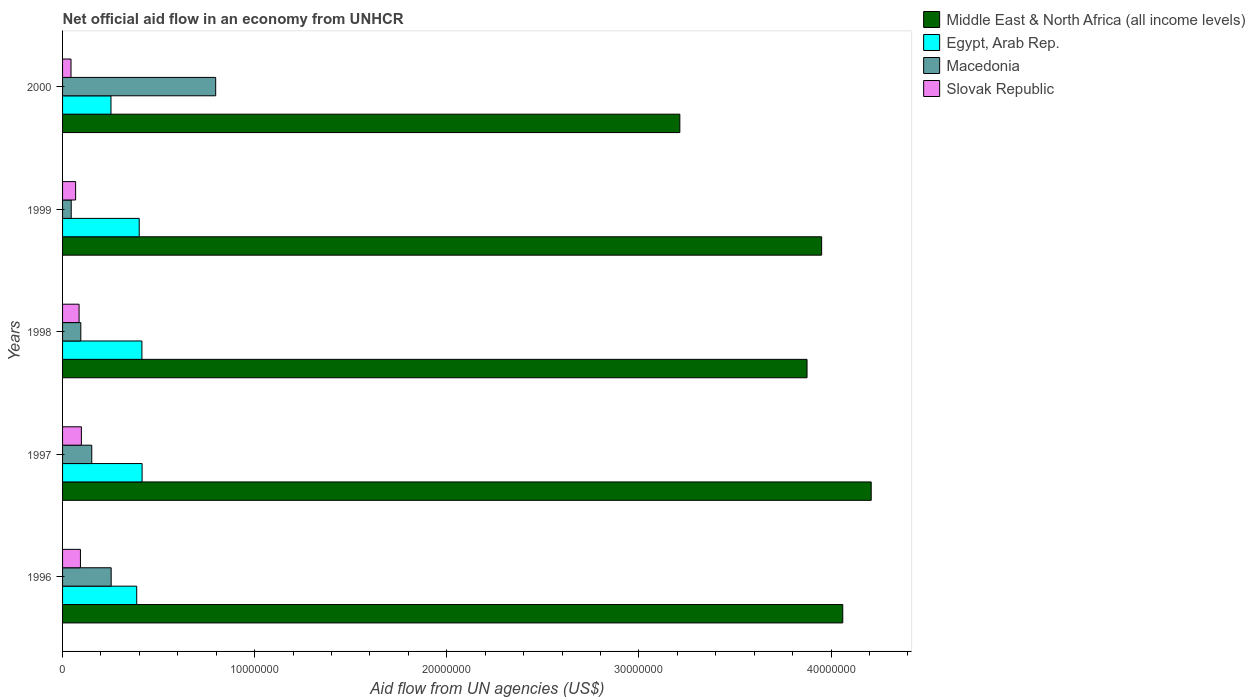How many different coloured bars are there?
Your answer should be compact. 4. How many groups of bars are there?
Make the answer very short. 5. How many bars are there on the 2nd tick from the top?
Give a very brief answer. 4. How many bars are there on the 3rd tick from the bottom?
Keep it short and to the point. 4. In how many cases, is the number of bars for a given year not equal to the number of legend labels?
Offer a very short reply. 0. What is the net official aid flow in Slovak Republic in 1997?
Ensure brevity in your answer.  9.80e+05. Across all years, what is the maximum net official aid flow in Egypt, Arab Rep.?
Ensure brevity in your answer.  4.14e+06. Across all years, what is the minimum net official aid flow in Slovak Republic?
Give a very brief answer. 4.40e+05. In which year was the net official aid flow in Macedonia maximum?
Ensure brevity in your answer.  2000. In which year was the net official aid flow in Slovak Republic minimum?
Offer a terse response. 2000. What is the total net official aid flow in Middle East & North Africa (all income levels) in the graph?
Provide a succinct answer. 1.93e+08. What is the difference between the net official aid flow in Macedonia in 1996 and that in 2000?
Your answer should be very brief. -5.44e+06. What is the difference between the net official aid flow in Egypt, Arab Rep. in 1998 and the net official aid flow in Macedonia in 1999?
Ensure brevity in your answer.  3.68e+06. What is the average net official aid flow in Macedonia per year?
Provide a short and direct response. 2.68e+06. In the year 1997, what is the difference between the net official aid flow in Egypt, Arab Rep. and net official aid flow in Slovak Republic?
Offer a very short reply. 3.16e+06. What is the ratio of the net official aid flow in Egypt, Arab Rep. in 1996 to that in 2000?
Make the answer very short. 1.53. What is the difference between the highest and the second highest net official aid flow in Middle East & North Africa (all income levels)?
Provide a succinct answer. 1.48e+06. What is the difference between the highest and the lowest net official aid flow in Middle East & North Africa (all income levels)?
Provide a succinct answer. 9.96e+06. In how many years, is the net official aid flow in Middle East & North Africa (all income levels) greater than the average net official aid flow in Middle East & North Africa (all income levels) taken over all years?
Offer a terse response. 4. What does the 3rd bar from the top in 1998 represents?
Your answer should be compact. Egypt, Arab Rep. What does the 3rd bar from the bottom in 1999 represents?
Make the answer very short. Macedonia. Is it the case that in every year, the sum of the net official aid flow in Egypt, Arab Rep. and net official aid flow in Macedonia is greater than the net official aid flow in Slovak Republic?
Your answer should be very brief. Yes. Are all the bars in the graph horizontal?
Offer a terse response. Yes. What is the difference between two consecutive major ticks on the X-axis?
Keep it short and to the point. 1.00e+07. Does the graph contain any zero values?
Give a very brief answer. No. Does the graph contain grids?
Offer a terse response. No. Where does the legend appear in the graph?
Ensure brevity in your answer.  Top right. How many legend labels are there?
Keep it short and to the point. 4. What is the title of the graph?
Provide a short and direct response. Net official aid flow in an economy from UNHCR. What is the label or title of the X-axis?
Provide a succinct answer. Aid flow from UN agencies (US$). What is the label or title of the Y-axis?
Your response must be concise. Years. What is the Aid flow from UN agencies (US$) of Middle East & North Africa (all income levels) in 1996?
Your answer should be very brief. 4.06e+07. What is the Aid flow from UN agencies (US$) in Egypt, Arab Rep. in 1996?
Provide a succinct answer. 3.86e+06. What is the Aid flow from UN agencies (US$) of Macedonia in 1996?
Provide a succinct answer. 2.53e+06. What is the Aid flow from UN agencies (US$) of Slovak Republic in 1996?
Offer a terse response. 9.30e+05. What is the Aid flow from UN agencies (US$) in Middle East & North Africa (all income levels) in 1997?
Make the answer very short. 4.21e+07. What is the Aid flow from UN agencies (US$) in Egypt, Arab Rep. in 1997?
Make the answer very short. 4.14e+06. What is the Aid flow from UN agencies (US$) in Macedonia in 1997?
Your answer should be very brief. 1.52e+06. What is the Aid flow from UN agencies (US$) in Slovak Republic in 1997?
Your answer should be compact. 9.80e+05. What is the Aid flow from UN agencies (US$) of Middle East & North Africa (all income levels) in 1998?
Ensure brevity in your answer.  3.88e+07. What is the Aid flow from UN agencies (US$) in Egypt, Arab Rep. in 1998?
Provide a short and direct response. 4.13e+06. What is the Aid flow from UN agencies (US$) in Macedonia in 1998?
Your response must be concise. 9.50e+05. What is the Aid flow from UN agencies (US$) in Slovak Republic in 1998?
Give a very brief answer. 8.60e+05. What is the Aid flow from UN agencies (US$) in Middle East & North Africa (all income levels) in 1999?
Provide a short and direct response. 3.95e+07. What is the Aid flow from UN agencies (US$) of Egypt, Arab Rep. in 1999?
Your response must be concise. 3.99e+06. What is the Aid flow from UN agencies (US$) of Slovak Republic in 1999?
Give a very brief answer. 6.80e+05. What is the Aid flow from UN agencies (US$) in Middle East & North Africa (all income levels) in 2000?
Your answer should be compact. 3.21e+07. What is the Aid flow from UN agencies (US$) of Egypt, Arab Rep. in 2000?
Keep it short and to the point. 2.52e+06. What is the Aid flow from UN agencies (US$) in Macedonia in 2000?
Your response must be concise. 7.97e+06. Across all years, what is the maximum Aid flow from UN agencies (US$) of Middle East & North Africa (all income levels)?
Make the answer very short. 4.21e+07. Across all years, what is the maximum Aid flow from UN agencies (US$) in Egypt, Arab Rep.?
Offer a very short reply. 4.14e+06. Across all years, what is the maximum Aid flow from UN agencies (US$) of Macedonia?
Give a very brief answer. 7.97e+06. Across all years, what is the maximum Aid flow from UN agencies (US$) of Slovak Republic?
Ensure brevity in your answer.  9.80e+05. Across all years, what is the minimum Aid flow from UN agencies (US$) of Middle East & North Africa (all income levels)?
Make the answer very short. 3.21e+07. Across all years, what is the minimum Aid flow from UN agencies (US$) in Egypt, Arab Rep.?
Make the answer very short. 2.52e+06. Across all years, what is the minimum Aid flow from UN agencies (US$) of Slovak Republic?
Ensure brevity in your answer.  4.40e+05. What is the total Aid flow from UN agencies (US$) in Middle East & North Africa (all income levels) in the graph?
Offer a terse response. 1.93e+08. What is the total Aid flow from UN agencies (US$) of Egypt, Arab Rep. in the graph?
Your answer should be very brief. 1.86e+07. What is the total Aid flow from UN agencies (US$) in Macedonia in the graph?
Keep it short and to the point. 1.34e+07. What is the total Aid flow from UN agencies (US$) in Slovak Republic in the graph?
Offer a terse response. 3.89e+06. What is the difference between the Aid flow from UN agencies (US$) of Middle East & North Africa (all income levels) in 1996 and that in 1997?
Make the answer very short. -1.48e+06. What is the difference between the Aid flow from UN agencies (US$) in Egypt, Arab Rep. in 1996 and that in 1997?
Offer a very short reply. -2.80e+05. What is the difference between the Aid flow from UN agencies (US$) in Macedonia in 1996 and that in 1997?
Ensure brevity in your answer.  1.01e+06. What is the difference between the Aid flow from UN agencies (US$) of Middle East & North Africa (all income levels) in 1996 and that in 1998?
Your answer should be compact. 1.86e+06. What is the difference between the Aid flow from UN agencies (US$) in Egypt, Arab Rep. in 1996 and that in 1998?
Make the answer very short. -2.70e+05. What is the difference between the Aid flow from UN agencies (US$) in Macedonia in 1996 and that in 1998?
Your response must be concise. 1.58e+06. What is the difference between the Aid flow from UN agencies (US$) in Slovak Republic in 1996 and that in 1998?
Your answer should be very brief. 7.00e+04. What is the difference between the Aid flow from UN agencies (US$) in Middle East & North Africa (all income levels) in 1996 and that in 1999?
Offer a terse response. 1.10e+06. What is the difference between the Aid flow from UN agencies (US$) of Macedonia in 1996 and that in 1999?
Your response must be concise. 2.08e+06. What is the difference between the Aid flow from UN agencies (US$) of Middle East & North Africa (all income levels) in 1996 and that in 2000?
Your answer should be very brief. 8.48e+06. What is the difference between the Aid flow from UN agencies (US$) of Egypt, Arab Rep. in 1996 and that in 2000?
Your response must be concise. 1.34e+06. What is the difference between the Aid flow from UN agencies (US$) in Macedonia in 1996 and that in 2000?
Provide a short and direct response. -5.44e+06. What is the difference between the Aid flow from UN agencies (US$) in Middle East & North Africa (all income levels) in 1997 and that in 1998?
Provide a succinct answer. 3.34e+06. What is the difference between the Aid flow from UN agencies (US$) of Macedonia in 1997 and that in 1998?
Offer a very short reply. 5.70e+05. What is the difference between the Aid flow from UN agencies (US$) in Middle East & North Africa (all income levels) in 1997 and that in 1999?
Your answer should be very brief. 2.58e+06. What is the difference between the Aid flow from UN agencies (US$) of Macedonia in 1997 and that in 1999?
Your answer should be compact. 1.07e+06. What is the difference between the Aid flow from UN agencies (US$) of Middle East & North Africa (all income levels) in 1997 and that in 2000?
Keep it short and to the point. 9.96e+06. What is the difference between the Aid flow from UN agencies (US$) of Egypt, Arab Rep. in 1997 and that in 2000?
Your answer should be compact. 1.62e+06. What is the difference between the Aid flow from UN agencies (US$) in Macedonia in 1997 and that in 2000?
Ensure brevity in your answer.  -6.45e+06. What is the difference between the Aid flow from UN agencies (US$) in Slovak Republic in 1997 and that in 2000?
Ensure brevity in your answer.  5.40e+05. What is the difference between the Aid flow from UN agencies (US$) of Middle East & North Africa (all income levels) in 1998 and that in 1999?
Provide a short and direct response. -7.60e+05. What is the difference between the Aid flow from UN agencies (US$) in Macedonia in 1998 and that in 1999?
Your answer should be very brief. 5.00e+05. What is the difference between the Aid flow from UN agencies (US$) in Middle East & North Africa (all income levels) in 1998 and that in 2000?
Make the answer very short. 6.62e+06. What is the difference between the Aid flow from UN agencies (US$) in Egypt, Arab Rep. in 1998 and that in 2000?
Give a very brief answer. 1.61e+06. What is the difference between the Aid flow from UN agencies (US$) of Macedonia in 1998 and that in 2000?
Provide a short and direct response. -7.02e+06. What is the difference between the Aid flow from UN agencies (US$) of Middle East & North Africa (all income levels) in 1999 and that in 2000?
Ensure brevity in your answer.  7.38e+06. What is the difference between the Aid flow from UN agencies (US$) in Egypt, Arab Rep. in 1999 and that in 2000?
Offer a very short reply. 1.47e+06. What is the difference between the Aid flow from UN agencies (US$) in Macedonia in 1999 and that in 2000?
Your answer should be very brief. -7.52e+06. What is the difference between the Aid flow from UN agencies (US$) of Slovak Republic in 1999 and that in 2000?
Give a very brief answer. 2.40e+05. What is the difference between the Aid flow from UN agencies (US$) in Middle East & North Africa (all income levels) in 1996 and the Aid flow from UN agencies (US$) in Egypt, Arab Rep. in 1997?
Give a very brief answer. 3.65e+07. What is the difference between the Aid flow from UN agencies (US$) in Middle East & North Africa (all income levels) in 1996 and the Aid flow from UN agencies (US$) in Macedonia in 1997?
Offer a terse response. 3.91e+07. What is the difference between the Aid flow from UN agencies (US$) in Middle East & North Africa (all income levels) in 1996 and the Aid flow from UN agencies (US$) in Slovak Republic in 1997?
Offer a very short reply. 3.96e+07. What is the difference between the Aid flow from UN agencies (US$) in Egypt, Arab Rep. in 1996 and the Aid flow from UN agencies (US$) in Macedonia in 1997?
Your response must be concise. 2.34e+06. What is the difference between the Aid flow from UN agencies (US$) of Egypt, Arab Rep. in 1996 and the Aid flow from UN agencies (US$) of Slovak Republic in 1997?
Provide a short and direct response. 2.88e+06. What is the difference between the Aid flow from UN agencies (US$) of Macedonia in 1996 and the Aid flow from UN agencies (US$) of Slovak Republic in 1997?
Your answer should be very brief. 1.55e+06. What is the difference between the Aid flow from UN agencies (US$) in Middle East & North Africa (all income levels) in 1996 and the Aid flow from UN agencies (US$) in Egypt, Arab Rep. in 1998?
Your answer should be compact. 3.65e+07. What is the difference between the Aid flow from UN agencies (US$) of Middle East & North Africa (all income levels) in 1996 and the Aid flow from UN agencies (US$) of Macedonia in 1998?
Offer a very short reply. 3.97e+07. What is the difference between the Aid flow from UN agencies (US$) in Middle East & North Africa (all income levels) in 1996 and the Aid flow from UN agencies (US$) in Slovak Republic in 1998?
Give a very brief answer. 3.98e+07. What is the difference between the Aid flow from UN agencies (US$) of Egypt, Arab Rep. in 1996 and the Aid flow from UN agencies (US$) of Macedonia in 1998?
Provide a succinct answer. 2.91e+06. What is the difference between the Aid flow from UN agencies (US$) of Egypt, Arab Rep. in 1996 and the Aid flow from UN agencies (US$) of Slovak Republic in 1998?
Provide a short and direct response. 3.00e+06. What is the difference between the Aid flow from UN agencies (US$) of Macedonia in 1996 and the Aid flow from UN agencies (US$) of Slovak Republic in 1998?
Provide a succinct answer. 1.67e+06. What is the difference between the Aid flow from UN agencies (US$) in Middle East & North Africa (all income levels) in 1996 and the Aid flow from UN agencies (US$) in Egypt, Arab Rep. in 1999?
Your answer should be very brief. 3.66e+07. What is the difference between the Aid flow from UN agencies (US$) in Middle East & North Africa (all income levels) in 1996 and the Aid flow from UN agencies (US$) in Macedonia in 1999?
Give a very brief answer. 4.02e+07. What is the difference between the Aid flow from UN agencies (US$) in Middle East & North Africa (all income levels) in 1996 and the Aid flow from UN agencies (US$) in Slovak Republic in 1999?
Offer a very short reply. 3.99e+07. What is the difference between the Aid flow from UN agencies (US$) of Egypt, Arab Rep. in 1996 and the Aid flow from UN agencies (US$) of Macedonia in 1999?
Keep it short and to the point. 3.41e+06. What is the difference between the Aid flow from UN agencies (US$) in Egypt, Arab Rep. in 1996 and the Aid flow from UN agencies (US$) in Slovak Republic in 1999?
Your answer should be compact. 3.18e+06. What is the difference between the Aid flow from UN agencies (US$) in Macedonia in 1996 and the Aid flow from UN agencies (US$) in Slovak Republic in 1999?
Your answer should be compact. 1.85e+06. What is the difference between the Aid flow from UN agencies (US$) of Middle East & North Africa (all income levels) in 1996 and the Aid flow from UN agencies (US$) of Egypt, Arab Rep. in 2000?
Provide a succinct answer. 3.81e+07. What is the difference between the Aid flow from UN agencies (US$) in Middle East & North Africa (all income levels) in 1996 and the Aid flow from UN agencies (US$) in Macedonia in 2000?
Provide a succinct answer. 3.26e+07. What is the difference between the Aid flow from UN agencies (US$) of Middle East & North Africa (all income levels) in 1996 and the Aid flow from UN agencies (US$) of Slovak Republic in 2000?
Make the answer very short. 4.02e+07. What is the difference between the Aid flow from UN agencies (US$) in Egypt, Arab Rep. in 1996 and the Aid flow from UN agencies (US$) in Macedonia in 2000?
Make the answer very short. -4.11e+06. What is the difference between the Aid flow from UN agencies (US$) of Egypt, Arab Rep. in 1996 and the Aid flow from UN agencies (US$) of Slovak Republic in 2000?
Offer a very short reply. 3.42e+06. What is the difference between the Aid flow from UN agencies (US$) of Macedonia in 1996 and the Aid flow from UN agencies (US$) of Slovak Republic in 2000?
Offer a very short reply. 2.09e+06. What is the difference between the Aid flow from UN agencies (US$) in Middle East & North Africa (all income levels) in 1997 and the Aid flow from UN agencies (US$) in Egypt, Arab Rep. in 1998?
Your answer should be compact. 3.80e+07. What is the difference between the Aid flow from UN agencies (US$) in Middle East & North Africa (all income levels) in 1997 and the Aid flow from UN agencies (US$) in Macedonia in 1998?
Ensure brevity in your answer.  4.11e+07. What is the difference between the Aid flow from UN agencies (US$) in Middle East & North Africa (all income levels) in 1997 and the Aid flow from UN agencies (US$) in Slovak Republic in 1998?
Your answer should be very brief. 4.12e+07. What is the difference between the Aid flow from UN agencies (US$) in Egypt, Arab Rep. in 1997 and the Aid flow from UN agencies (US$) in Macedonia in 1998?
Your answer should be compact. 3.19e+06. What is the difference between the Aid flow from UN agencies (US$) of Egypt, Arab Rep. in 1997 and the Aid flow from UN agencies (US$) of Slovak Republic in 1998?
Provide a succinct answer. 3.28e+06. What is the difference between the Aid flow from UN agencies (US$) of Macedonia in 1997 and the Aid flow from UN agencies (US$) of Slovak Republic in 1998?
Offer a terse response. 6.60e+05. What is the difference between the Aid flow from UN agencies (US$) in Middle East & North Africa (all income levels) in 1997 and the Aid flow from UN agencies (US$) in Egypt, Arab Rep. in 1999?
Make the answer very short. 3.81e+07. What is the difference between the Aid flow from UN agencies (US$) of Middle East & North Africa (all income levels) in 1997 and the Aid flow from UN agencies (US$) of Macedonia in 1999?
Ensure brevity in your answer.  4.16e+07. What is the difference between the Aid flow from UN agencies (US$) of Middle East & North Africa (all income levels) in 1997 and the Aid flow from UN agencies (US$) of Slovak Republic in 1999?
Ensure brevity in your answer.  4.14e+07. What is the difference between the Aid flow from UN agencies (US$) of Egypt, Arab Rep. in 1997 and the Aid flow from UN agencies (US$) of Macedonia in 1999?
Keep it short and to the point. 3.69e+06. What is the difference between the Aid flow from UN agencies (US$) in Egypt, Arab Rep. in 1997 and the Aid flow from UN agencies (US$) in Slovak Republic in 1999?
Your answer should be compact. 3.46e+06. What is the difference between the Aid flow from UN agencies (US$) of Macedonia in 1997 and the Aid flow from UN agencies (US$) of Slovak Republic in 1999?
Give a very brief answer. 8.40e+05. What is the difference between the Aid flow from UN agencies (US$) in Middle East & North Africa (all income levels) in 1997 and the Aid flow from UN agencies (US$) in Egypt, Arab Rep. in 2000?
Your response must be concise. 3.96e+07. What is the difference between the Aid flow from UN agencies (US$) of Middle East & North Africa (all income levels) in 1997 and the Aid flow from UN agencies (US$) of Macedonia in 2000?
Give a very brief answer. 3.41e+07. What is the difference between the Aid flow from UN agencies (US$) of Middle East & North Africa (all income levels) in 1997 and the Aid flow from UN agencies (US$) of Slovak Republic in 2000?
Provide a succinct answer. 4.16e+07. What is the difference between the Aid flow from UN agencies (US$) in Egypt, Arab Rep. in 1997 and the Aid flow from UN agencies (US$) in Macedonia in 2000?
Give a very brief answer. -3.83e+06. What is the difference between the Aid flow from UN agencies (US$) in Egypt, Arab Rep. in 1997 and the Aid flow from UN agencies (US$) in Slovak Republic in 2000?
Make the answer very short. 3.70e+06. What is the difference between the Aid flow from UN agencies (US$) in Macedonia in 1997 and the Aid flow from UN agencies (US$) in Slovak Republic in 2000?
Keep it short and to the point. 1.08e+06. What is the difference between the Aid flow from UN agencies (US$) in Middle East & North Africa (all income levels) in 1998 and the Aid flow from UN agencies (US$) in Egypt, Arab Rep. in 1999?
Offer a very short reply. 3.48e+07. What is the difference between the Aid flow from UN agencies (US$) in Middle East & North Africa (all income levels) in 1998 and the Aid flow from UN agencies (US$) in Macedonia in 1999?
Provide a succinct answer. 3.83e+07. What is the difference between the Aid flow from UN agencies (US$) in Middle East & North Africa (all income levels) in 1998 and the Aid flow from UN agencies (US$) in Slovak Republic in 1999?
Your answer should be very brief. 3.81e+07. What is the difference between the Aid flow from UN agencies (US$) of Egypt, Arab Rep. in 1998 and the Aid flow from UN agencies (US$) of Macedonia in 1999?
Make the answer very short. 3.68e+06. What is the difference between the Aid flow from UN agencies (US$) in Egypt, Arab Rep. in 1998 and the Aid flow from UN agencies (US$) in Slovak Republic in 1999?
Keep it short and to the point. 3.45e+06. What is the difference between the Aid flow from UN agencies (US$) in Middle East & North Africa (all income levels) in 1998 and the Aid flow from UN agencies (US$) in Egypt, Arab Rep. in 2000?
Your response must be concise. 3.62e+07. What is the difference between the Aid flow from UN agencies (US$) of Middle East & North Africa (all income levels) in 1998 and the Aid flow from UN agencies (US$) of Macedonia in 2000?
Provide a short and direct response. 3.08e+07. What is the difference between the Aid flow from UN agencies (US$) of Middle East & North Africa (all income levels) in 1998 and the Aid flow from UN agencies (US$) of Slovak Republic in 2000?
Keep it short and to the point. 3.83e+07. What is the difference between the Aid flow from UN agencies (US$) in Egypt, Arab Rep. in 1998 and the Aid flow from UN agencies (US$) in Macedonia in 2000?
Ensure brevity in your answer.  -3.84e+06. What is the difference between the Aid flow from UN agencies (US$) of Egypt, Arab Rep. in 1998 and the Aid flow from UN agencies (US$) of Slovak Republic in 2000?
Offer a terse response. 3.69e+06. What is the difference between the Aid flow from UN agencies (US$) of Macedonia in 1998 and the Aid flow from UN agencies (US$) of Slovak Republic in 2000?
Provide a succinct answer. 5.10e+05. What is the difference between the Aid flow from UN agencies (US$) in Middle East & North Africa (all income levels) in 1999 and the Aid flow from UN agencies (US$) in Egypt, Arab Rep. in 2000?
Your answer should be compact. 3.70e+07. What is the difference between the Aid flow from UN agencies (US$) of Middle East & North Africa (all income levels) in 1999 and the Aid flow from UN agencies (US$) of Macedonia in 2000?
Offer a terse response. 3.15e+07. What is the difference between the Aid flow from UN agencies (US$) of Middle East & North Africa (all income levels) in 1999 and the Aid flow from UN agencies (US$) of Slovak Republic in 2000?
Provide a short and direct response. 3.91e+07. What is the difference between the Aid flow from UN agencies (US$) in Egypt, Arab Rep. in 1999 and the Aid flow from UN agencies (US$) in Macedonia in 2000?
Offer a very short reply. -3.98e+06. What is the difference between the Aid flow from UN agencies (US$) of Egypt, Arab Rep. in 1999 and the Aid flow from UN agencies (US$) of Slovak Republic in 2000?
Keep it short and to the point. 3.55e+06. What is the average Aid flow from UN agencies (US$) in Middle East & North Africa (all income levels) per year?
Keep it short and to the point. 3.86e+07. What is the average Aid flow from UN agencies (US$) of Egypt, Arab Rep. per year?
Keep it short and to the point. 3.73e+06. What is the average Aid flow from UN agencies (US$) of Macedonia per year?
Provide a succinct answer. 2.68e+06. What is the average Aid flow from UN agencies (US$) of Slovak Republic per year?
Offer a terse response. 7.78e+05. In the year 1996, what is the difference between the Aid flow from UN agencies (US$) of Middle East & North Africa (all income levels) and Aid flow from UN agencies (US$) of Egypt, Arab Rep.?
Make the answer very short. 3.68e+07. In the year 1996, what is the difference between the Aid flow from UN agencies (US$) of Middle East & North Africa (all income levels) and Aid flow from UN agencies (US$) of Macedonia?
Provide a succinct answer. 3.81e+07. In the year 1996, what is the difference between the Aid flow from UN agencies (US$) of Middle East & North Africa (all income levels) and Aid flow from UN agencies (US$) of Slovak Republic?
Your response must be concise. 3.97e+07. In the year 1996, what is the difference between the Aid flow from UN agencies (US$) of Egypt, Arab Rep. and Aid flow from UN agencies (US$) of Macedonia?
Make the answer very short. 1.33e+06. In the year 1996, what is the difference between the Aid flow from UN agencies (US$) of Egypt, Arab Rep. and Aid flow from UN agencies (US$) of Slovak Republic?
Ensure brevity in your answer.  2.93e+06. In the year 1996, what is the difference between the Aid flow from UN agencies (US$) in Macedonia and Aid flow from UN agencies (US$) in Slovak Republic?
Provide a succinct answer. 1.60e+06. In the year 1997, what is the difference between the Aid flow from UN agencies (US$) in Middle East & North Africa (all income levels) and Aid flow from UN agencies (US$) in Egypt, Arab Rep.?
Give a very brief answer. 3.80e+07. In the year 1997, what is the difference between the Aid flow from UN agencies (US$) of Middle East & North Africa (all income levels) and Aid flow from UN agencies (US$) of Macedonia?
Provide a succinct answer. 4.06e+07. In the year 1997, what is the difference between the Aid flow from UN agencies (US$) of Middle East & North Africa (all income levels) and Aid flow from UN agencies (US$) of Slovak Republic?
Make the answer very short. 4.11e+07. In the year 1997, what is the difference between the Aid flow from UN agencies (US$) in Egypt, Arab Rep. and Aid flow from UN agencies (US$) in Macedonia?
Give a very brief answer. 2.62e+06. In the year 1997, what is the difference between the Aid flow from UN agencies (US$) of Egypt, Arab Rep. and Aid flow from UN agencies (US$) of Slovak Republic?
Your response must be concise. 3.16e+06. In the year 1997, what is the difference between the Aid flow from UN agencies (US$) in Macedonia and Aid flow from UN agencies (US$) in Slovak Republic?
Provide a short and direct response. 5.40e+05. In the year 1998, what is the difference between the Aid flow from UN agencies (US$) of Middle East & North Africa (all income levels) and Aid flow from UN agencies (US$) of Egypt, Arab Rep.?
Keep it short and to the point. 3.46e+07. In the year 1998, what is the difference between the Aid flow from UN agencies (US$) in Middle East & North Africa (all income levels) and Aid flow from UN agencies (US$) in Macedonia?
Your response must be concise. 3.78e+07. In the year 1998, what is the difference between the Aid flow from UN agencies (US$) of Middle East & North Africa (all income levels) and Aid flow from UN agencies (US$) of Slovak Republic?
Offer a terse response. 3.79e+07. In the year 1998, what is the difference between the Aid flow from UN agencies (US$) in Egypt, Arab Rep. and Aid flow from UN agencies (US$) in Macedonia?
Keep it short and to the point. 3.18e+06. In the year 1998, what is the difference between the Aid flow from UN agencies (US$) in Egypt, Arab Rep. and Aid flow from UN agencies (US$) in Slovak Republic?
Your response must be concise. 3.27e+06. In the year 1998, what is the difference between the Aid flow from UN agencies (US$) in Macedonia and Aid flow from UN agencies (US$) in Slovak Republic?
Your answer should be very brief. 9.00e+04. In the year 1999, what is the difference between the Aid flow from UN agencies (US$) of Middle East & North Africa (all income levels) and Aid flow from UN agencies (US$) of Egypt, Arab Rep.?
Offer a terse response. 3.55e+07. In the year 1999, what is the difference between the Aid flow from UN agencies (US$) in Middle East & North Africa (all income levels) and Aid flow from UN agencies (US$) in Macedonia?
Offer a terse response. 3.91e+07. In the year 1999, what is the difference between the Aid flow from UN agencies (US$) in Middle East & North Africa (all income levels) and Aid flow from UN agencies (US$) in Slovak Republic?
Keep it short and to the point. 3.88e+07. In the year 1999, what is the difference between the Aid flow from UN agencies (US$) of Egypt, Arab Rep. and Aid flow from UN agencies (US$) of Macedonia?
Give a very brief answer. 3.54e+06. In the year 1999, what is the difference between the Aid flow from UN agencies (US$) in Egypt, Arab Rep. and Aid flow from UN agencies (US$) in Slovak Republic?
Provide a short and direct response. 3.31e+06. In the year 2000, what is the difference between the Aid flow from UN agencies (US$) in Middle East & North Africa (all income levels) and Aid flow from UN agencies (US$) in Egypt, Arab Rep.?
Your answer should be very brief. 2.96e+07. In the year 2000, what is the difference between the Aid flow from UN agencies (US$) of Middle East & North Africa (all income levels) and Aid flow from UN agencies (US$) of Macedonia?
Provide a succinct answer. 2.42e+07. In the year 2000, what is the difference between the Aid flow from UN agencies (US$) of Middle East & North Africa (all income levels) and Aid flow from UN agencies (US$) of Slovak Republic?
Your response must be concise. 3.17e+07. In the year 2000, what is the difference between the Aid flow from UN agencies (US$) of Egypt, Arab Rep. and Aid flow from UN agencies (US$) of Macedonia?
Give a very brief answer. -5.45e+06. In the year 2000, what is the difference between the Aid flow from UN agencies (US$) of Egypt, Arab Rep. and Aid flow from UN agencies (US$) of Slovak Republic?
Offer a terse response. 2.08e+06. In the year 2000, what is the difference between the Aid flow from UN agencies (US$) of Macedonia and Aid flow from UN agencies (US$) of Slovak Republic?
Offer a terse response. 7.53e+06. What is the ratio of the Aid flow from UN agencies (US$) of Middle East & North Africa (all income levels) in 1996 to that in 1997?
Make the answer very short. 0.96. What is the ratio of the Aid flow from UN agencies (US$) of Egypt, Arab Rep. in 1996 to that in 1997?
Provide a short and direct response. 0.93. What is the ratio of the Aid flow from UN agencies (US$) of Macedonia in 1996 to that in 1997?
Provide a short and direct response. 1.66. What is the ratio of the Aid flow from UN agencies (US$) of Slovak Republic in 1996 to that in 1997?
Give a very brief answer. 0.95. What is the ratio of the Aid flow from UN agencies (US$) of Middle East & North Africa (all income levels) in 1996 to that in 1998?
Make the answer very short. 1.05. What is the ratio of the Aid flow from UN agencies (US$) in Egypt, Arab Rep. in 1996 to that in 1998?
Your response must be concise. 0.93. What is the ratio of the Aid flow from UN agencies (US$) of Macedonia in 1996 to that in 1998?
Provide a short and direct response. 2.66. What is the ratio of the Aid flow from UN agencies (US$) of Slovak Republic in 1996 to that in 1998?
Offer a terse response. 1.08. What is the ratio of the Aid flow from UN agencies (US$) in Middle East & North Africa (all income levels) in 1996 to that in 1999?
Offer a very short reply. 1.03. What is the ratio of the Aid flow from UN agencies (US$) in Egypt, Arab Rep. in 1996 to that in 1999?
Provide a succinct answer. 0.97. What is the ratio of the Aid flow from UN agencies (US$) in Macedonia in 1996 to that in 1999?
Your answer should be very brief. 5.62. What is the ratio of the Aid flow from UN agencies (US$) of Slovak Republic in 1996 to that in 1999?
Provide a succinct answer. 1.37. What is the ratio of the Aid flow from UN agencies (US$) of Middle East & North Africa (all income levels) in 1996 to that in 2000?
Offer a very short reply. 1.26. What is the ratio of the Aid flow from UN agencies (US$) in Egypt, Arab Rep. in 1996 to that in 2000?
Provide a succinct answer. 1.53. What is the ratio of the Aid flow from UN agencies (US$) in Macedonia in 1996 to that in 2000?
Ensure brevity in your answer.  0.32. What is the ratio of the Aid flow from UN agencies (US$) in Slovak Republic in 1996 to that in 2000?
Give a very brief answer. 2.11. What is the ratio of the Aid flow from UN agencies (US$) in Middle East & North Africa (all income levels) in 1997 to that in 1998?
Your response must be concise. 1.09. What is the ratio of the Aid flow from UN agencies (US$) of Slovak Republic in 1997 to that in 1998?
Keep it short and to the point. 1.14. What is the ratio of the Aid flow from UN agencies (US$) in Middle East & North Africa (all income levels) in 1997 to that in 1999?
Offer a terse response. 1.07. What is the ratio of the Aid flow from UN agencies (US$) in Egypt, Arab Rep. in 1997 to that in 1999?
Provide a succinct answer. 1.04. What is the ratio of the Aid flow from UN agencies (US$) of Macedonia in 1997 to that in 1999?
Make the answer very short. 3.38. What is the ratio of the Aid flow from UN agencies (US$) in Slovak Republic in 1997 to that in 1999?
Provide a succinct answer. 1.44. What is the ratio of the Aid flow from UN agencies (US$) of Middle East & North Africa (all income levels) in 1997 to that in 2000?
Keep it short and to the point. 1.31. What is the ratio of the Aid flow from UN agencies (US$) of Egypt, Arab Rep. in 1997 to that in 2000?
Your answer should be compact. 1.64. What is the ratio of the Aid flow from UN agencies (US$) in Macedonia in 1997 to that in 2000?
Ensure brevity in your answer.  0.19. What is the ratio of the Aid flow from UN agencies (US$) in Slovak Republic in 1997 to that in 2000?
Offer a very short reply. 2.23. What is the ratio of the Aid flow from UN agencies (US$) in Middle East & North Africa (all income levels) in 1998 to that in 1999?
Give a very brief answer. 0.98. What is the ratio of the Aid flow from UN agencies (US$) of Egypt, Arab Rep. in 1998 to that in 1999?
Ensure brevity in your answer.  1.04. What is the ratio of the Aid flow from UN agencies (US$) of Macedonia in 1998 to that in 1999?
Keep it short and to the point. 2.11. What is the ratio of the Aid flow from UN agencies (US$) of Slovak Republic in 1998 to that in 1999?
Your response must be concise. 1.26. What is the ratio of the Aid flow from UN agencies (US$) in Middle East & North Africa (all income levels) in 1998 to that in 2000?
Give a very brief answer. 1.21. What is the ratio of the Aid flow from UN agencies (US$) in Egypt, Arab Rep. in 1998 to that in 2000?
Keep it short and to the point. 1.64. What is the ratio of the Aid flow from UN agencies (US$) in Macedonia in 1998 to that in 2000?
Your answer should be compact. 0.12. What is the ratio of the Aid flow from UN agencies (US$) of Slovak Republic in 1998 to that in 2000?
Your response must be concise. 1.95. What is the ratio of the Aid flow from UN agencies (US$) in Middle East & North Africa (all income levels) in 1999 to that in 2000?
Make the answer very short. 1.23. What is the ratio of the Aid flow from UN agencies (US$) of Egypt, Arab Rep. in 1999 to that in 2000?
Your answer should be very brief. 1.58. What is the ratio of the Aid flow from UN agencies (US$) in Macedonia in 1999 to that in 2000?
Provide a short and direct response. 0.06. What is the ratio of the Aid flow from UN agencies (US$) in Slovak Republic in 1999 to that in 2000?
Your answer should be compact. 1.55. What is the difference between the highest and the second highest Aid flow from UN agencies (US$) in Middle East & North Africa (all income levels)?
Your answer should be compact. 1.48e+06. What is the difference between the highest and the second highest Aid flow from UN agencies (US$) of Egypt, Arab Rep.?
Your answer should be compact. 10000. What is the difference between the highest and the second highest Aid flow from UN agencies (US$) of Macedonia?
Provide a short and direct response. 5.44e+06. What is the difference between the highest and the lowest Aid flow from UN agencies (US$) of Middle East & North Africa (all income levels)?
Offer a terse response. 9.96e+06. What is the difference between the highest and the lowest Aid flow from UN agencies (US$) in Egypt, Arab Rep.?
Offer a very short reply. 1.62e+06. What is the difference between the highest and the lowest Aid flow from UN agencies (US$) in Macedonia?
Offer a terse response. 7.52e+06. What is the difference between the highest and the lowest Aid flow from UN agencies (US$) of Slovak Republic?
Make the answer very short. 5.40e+05. 